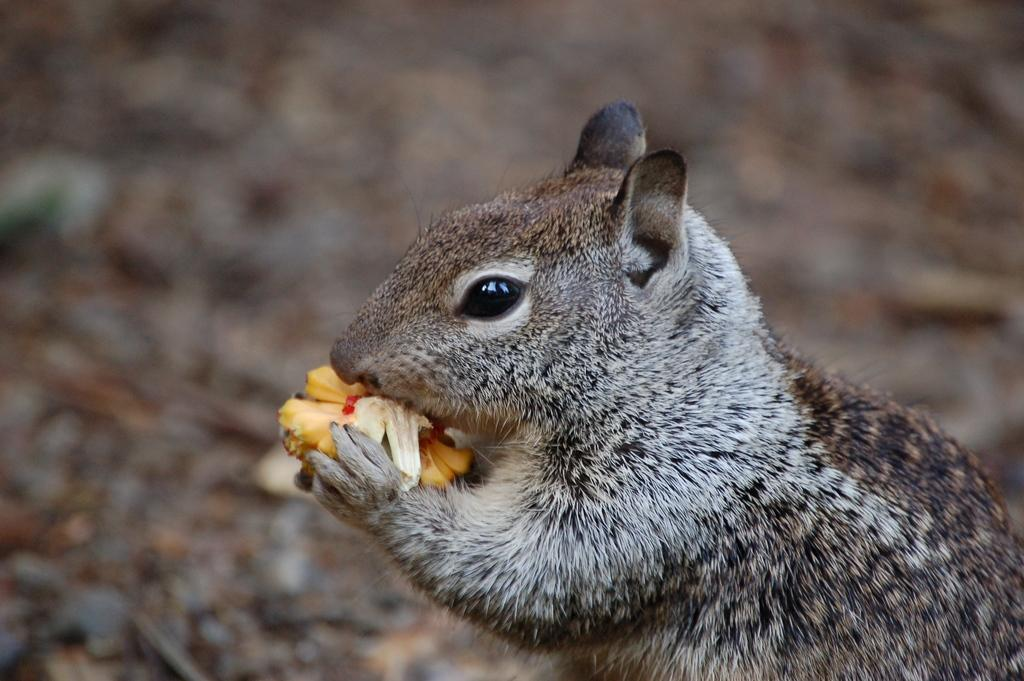What animal can be seen in the image? There is a squirrel in the image. What is the squirrel doing in the image? The squirrel is eating food in the image. Can you describe the background of the image? The background of the image is blurred. What country is the squirrel from in the image? There is no information about the country of origin of the squirrel in the image. Is there a flame visible in the image? No, there is no flame present in the image. 